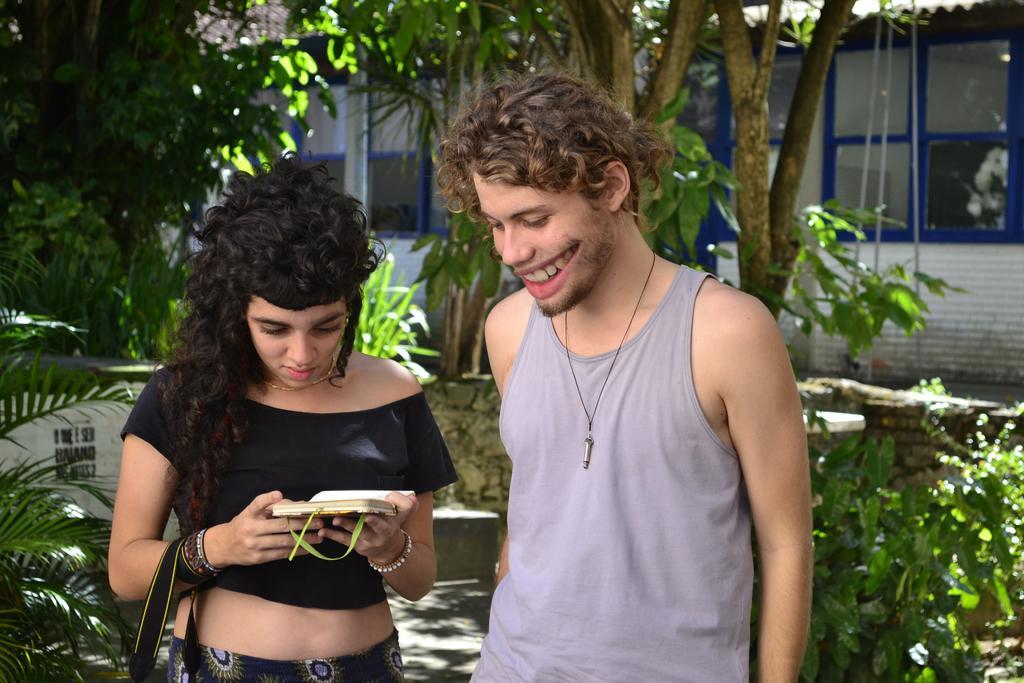Can you describe this image briefly? In this image we can see this woman wearing black dress is holding some object in her hands and this man standing here is smiling. In the background, we can see the plants, trees, the wall and the house. 